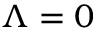<formula> <loc_0><loc_0><loc_500><loc_500>\Lambda = 0</formula> 